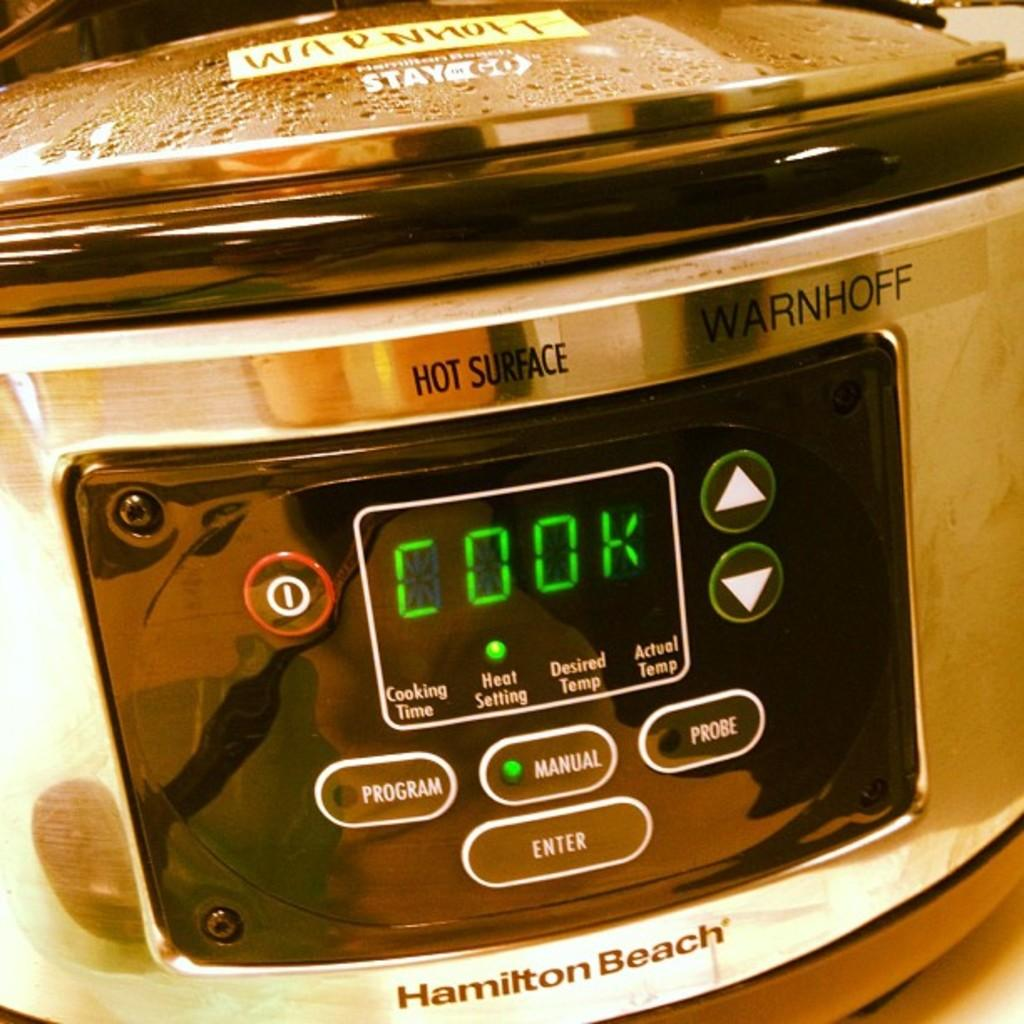Provide a one-sentence caption for the provided image. An appliance by Hamilton Beach says cook on the screen. 